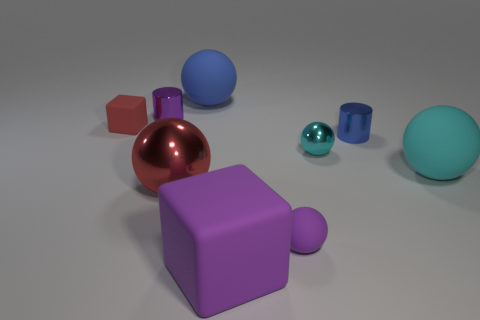Subtract all blue spheres. How many spheres are left? 4 Subtract all purple blocks. How many blocks are left? 1 Add 1 large green matte cylinders. How many objects exist? 10 Subtract 0 yellow cylinders. How many objects are left? 9 Subtract all spheres. How many objects are left? 4 Subtract 1 spheres. How many spheres are left? 4 Subtract all red cubes. Subtract all yellow cylinders. How many cubes are left? 1 Subtract all gray cylinders. How many blue blocks are left? 0 Subtract all small blocks. Subtract all big blue rubber objects. How many objects are left? 7 Add 8 blue matte spheres. How many blue matte spheres are left? 9 